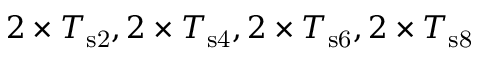<formula> <loc_0><loc_0><loc_500><loc_500>2 \times T _ { s 2 } , 2 \times T _ { s 4 } , 2 \times T _ { s 6 } , 2 \times T _ { s 8 }</formula> 